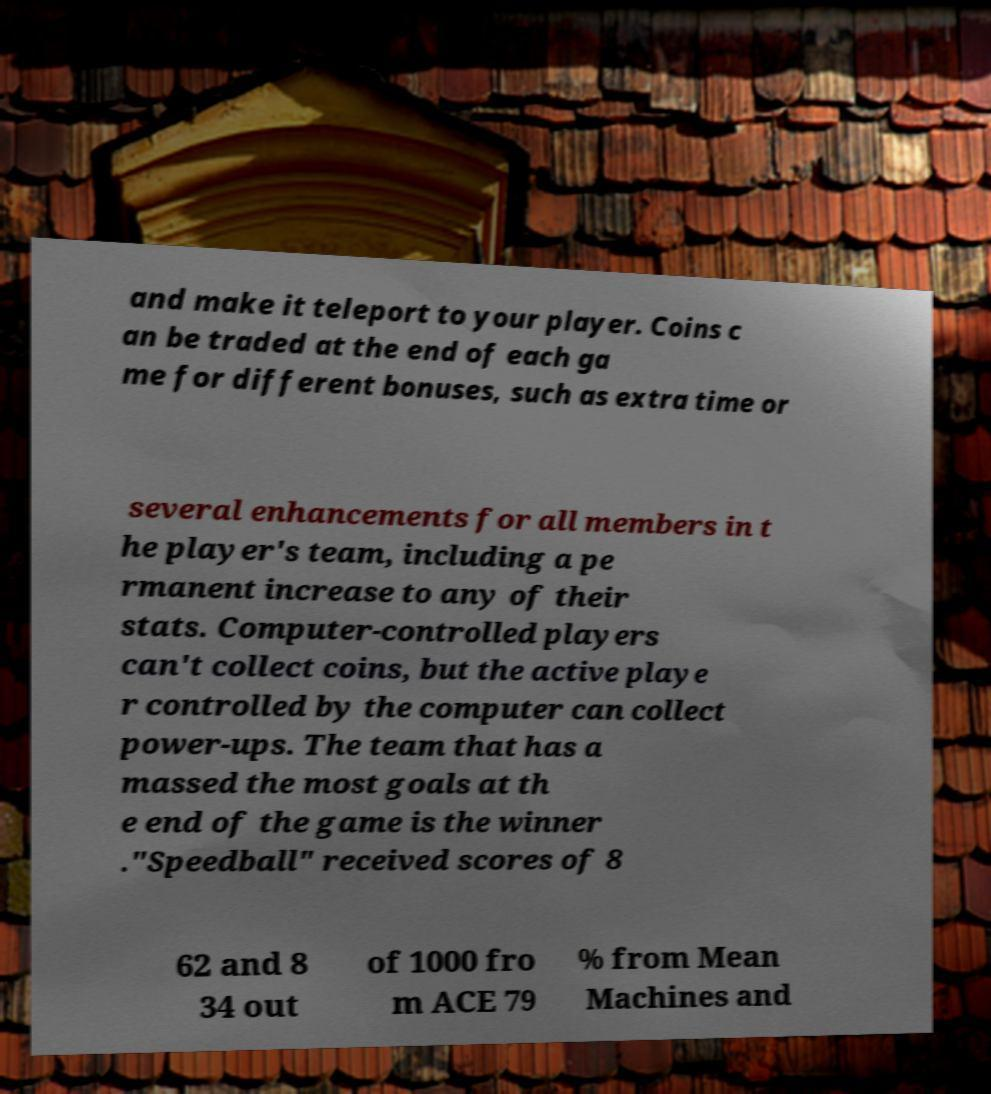Can you accurately transcribe the text from the provided image for me? and make it teleport to your player. Coins c an be traded at the end of each ga me for different bonuses, such as extra time or several enhancements for all members in t he player's team, including a pe rmanent increase to any of their stats. Computer-controlled players can't collect coins, but the active playe r controlled by the computer can collect power-ups. The team that has a massed the most goals at th e end of the game is the winner ."Speedball" received scores of 8 62 and 8 34 out of 1000 fro m ACE 79 % from Mean Machines and 